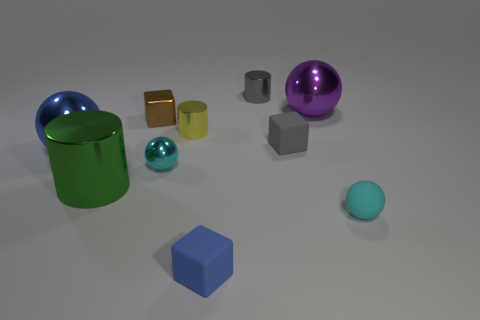Subtract all gray cylinders. How many cylinders are left? 2 Subtract all gray cylinders. How many cylinders are left? 2 Add 1 large gray balls. How many large gray balls exist? 1 Subtract 0 yellow balls. How many objects are left? 10 Subtract all balls. How many objects are left? 6 Subtract 1 cubes. How many cubes are left? 2 Subtract all yellow balls. Subtract all brown cubes. How many balls are left? 4 Subtract all yellow spheres. How many brown cylinders are left? 0 Subtract all big blue objects. Subtract all purple balls. How many objects are left? 8 Add 6 yellow metallic cylinders. How many yellow metallic cylinders are left? 7 